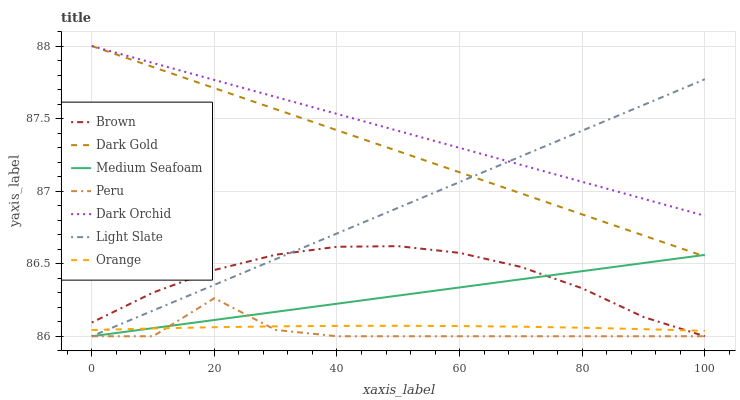Does Peru have the minimum area under the curve?
Answer yes or no. Yes. Does Dark Orchid have the maximum area under the curve?
Answer yes or no. Yes. Does Dark Gold have the minimum area under the curve?
Answer yes or no. No. Does Dark Gold have the maximum area under the curve?
Answer yes or no. No. Is Dark Orchid the smoothest?
Answer yes or no. Yes. Is Peru the roughest?
Answer yes or no. Yes. Is Dark Gold the smoothest?
Answer yes or no. No. Is Dark Gold the roughest?
Answer yes or no. No. Does Dark Gold have the lowest value?
Answer yes or no. No. Does Dark Orchid have the highest value?
Answer yes or no. Yes. Does Light Slate have the highest value?
Answer yes or no. No. Is Peru less than Dark Orchid?
Answer yes or no. Yes. Is Dark Orchid greater than Orange?
Answer yes or no. Yes. Does Peru intersect Dark Orchid?
Answer yes or no. No. 